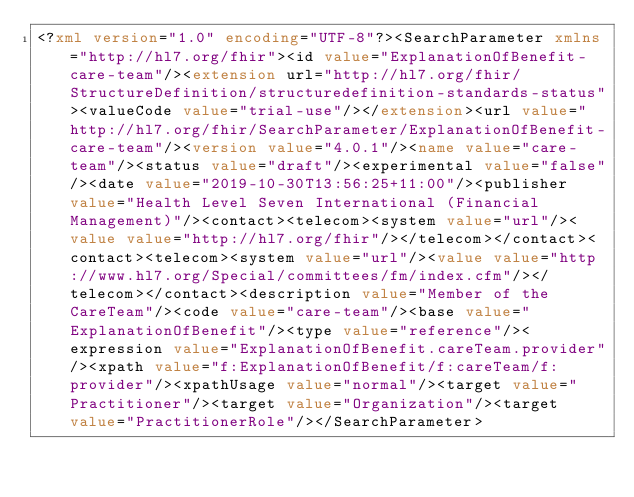<code> <loc_0><loc_0><loc_500><loc_500><_XML_><?xml version="1.0" encoding="UTF-8"?><SearchParameter xmlns="http://hl7.org/fhir"><id value="ExplanationOfBenefit-care-team"/><extension url="http://hl7.org/fhir/StructureDefinition/structuredefinition-standards-status"><valueCode value="trial-use"/></extension><url value="http://hl7.org/fhir/SearchParameter/ExplanationOfBenefit-care-team"/><version value="4.0.1"/><name value="care-team"/><status value="draft"/><experimental value="false"/><date value="2019-10-30T13:56:25+11:00"/><publisher value="Health Level Seven International (Financial Management)"/><contact><telecom><system value="url"/><value value="http://hl7.org/fhir"/></telecom></contact><contact><telecom><system value="url"/><value value="http://www.hl7.org/Special/committees/fm/index.cfm"/></telecom></contact><description value="Member of the CareTeam"/><code value="care-team"/><base value="ExplanationOfBenefit"/><type value="reference"/><expression value="ExplanationOfBenefit.careTeam.provider"/><xpath value="f:ExplanationOfBenefit/f:careTeam/f:provider"/><xpathUsage value="normal"/><target value="Practitioner"/><target value="Organization"/><target value="PractitionerRole"/></SearchParameter></code> 